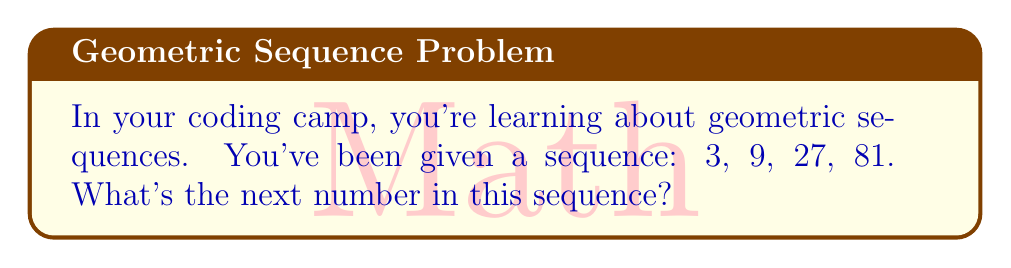Can you answer this question? Let's approach this step-by-step:

1) In a geometric sequence, each term is found by multiplying the previous term by a constant. This constant is called the common ratio.

2) To find the common ratio, we can divide any term by the previous term:

   $\frac{9}{3} = 3$
   $\frac{27}{9} = 3$
   $\frac{81}{27} = 3$

3) We can see that the common ratio is 3.

4) To find the next term, we multiply the last given term by the common ratio:

   $81 \times 3 = 243$

Therefore, the next number in the sequence will be 243.
Answer: 243 